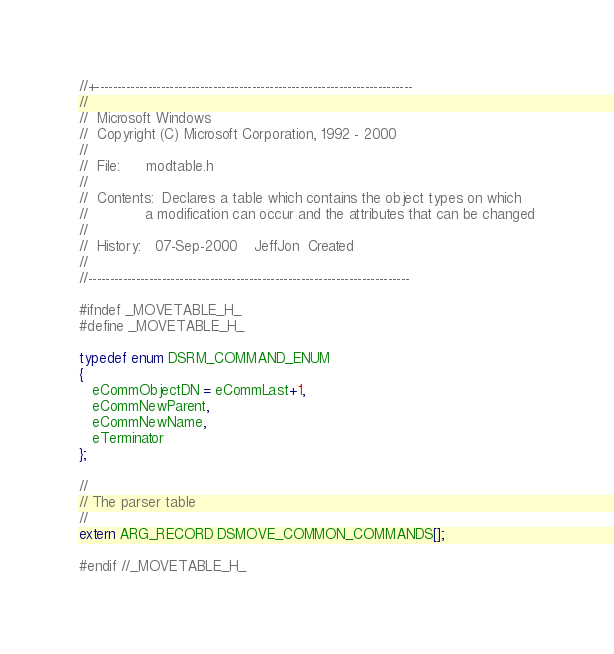<code> <loc_0><loc_0><loc_500><loc_500><_C_>//+-------------------------------------------------------------------------
//
//  Microsoft Windows
//  Copyright (C) Microsoft Corporation, 1992 - 2000
//
//  File:      modtable.h
//
//  Contents:  Declares a table which contains the object types on which
//             a modification can occur and the attributes that can be changed
//
//  History:   07-Sep-2000    JeffJon  Created
//
//--------------------------------------------------------------------------

#ifndef _MOVETABLE_H_
#define _MOVETABLE_H_

typedef enum DSRM_COMMAND_ENUM
{
   eCommObjectDN = eCommLast+1,   
   eCommNewParent,
   eCommNewName,
   eTerminator
};

//
// The parser table
//
extern ARG_RECORD DSMOVE_COMMON_COMMANDS[];

#endif //_MOVETABLE_H_</code> 